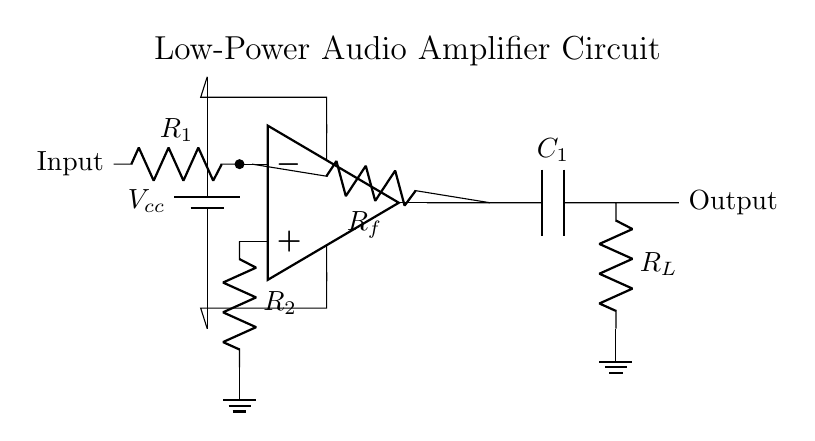What component is used for amplification? The operational amplifier, represented as "op amp," is the key component responsible for amplification in the circuit. It takes the input signal and increases its amplitude to drive the output.
Answer: op amp What is the role of the feedback resistor? The feedback resistor, labeled as Rf, provides a path for a portion of the output signal back to the inverting input of the op amp. This configuration helps stabilize the gain of the amplifier and controls the overall performance of the circuit.
Answer: Stabilize gain What is the input to this circuit? The input of the circuit is clearly labeled and is connected to the non-inverting terminal of the op amp. This indicates that an audio signal from a small radio or music player is expected as input.
Answer: Audio signal Which component is connected to ground? The component connected to ground in the circuit is the resistor labeled as R2. This connection provides a reference point for the op amp and completes the circuit.
Answer: R2 What is the function of the capacitor in this circuit? The capacitor, labeled as C1, allows AC signals to pass while blocking DC. This configuration is essential for coupling the amplified audio signal to the load without affecting the DC bias conditions of the circuit.
Answer: Coupling How many resistors are present in the circuit? There are three resistors visible in the circuit: R1, R2, and Rf. They play different roles in the input stage and feedback loop of the amplifier, impacting the gain and response of the circuit.
Answer: Three What voltage is supplied to the circuit? The voltage supply, labeled as Vcc, is crucial for powering the op amp. It indicates that the circuit requires an external voltage source to function correctly. The specific value should be determined based on op amp specifications but is not shown on the diagram.
Answer: Vcc 